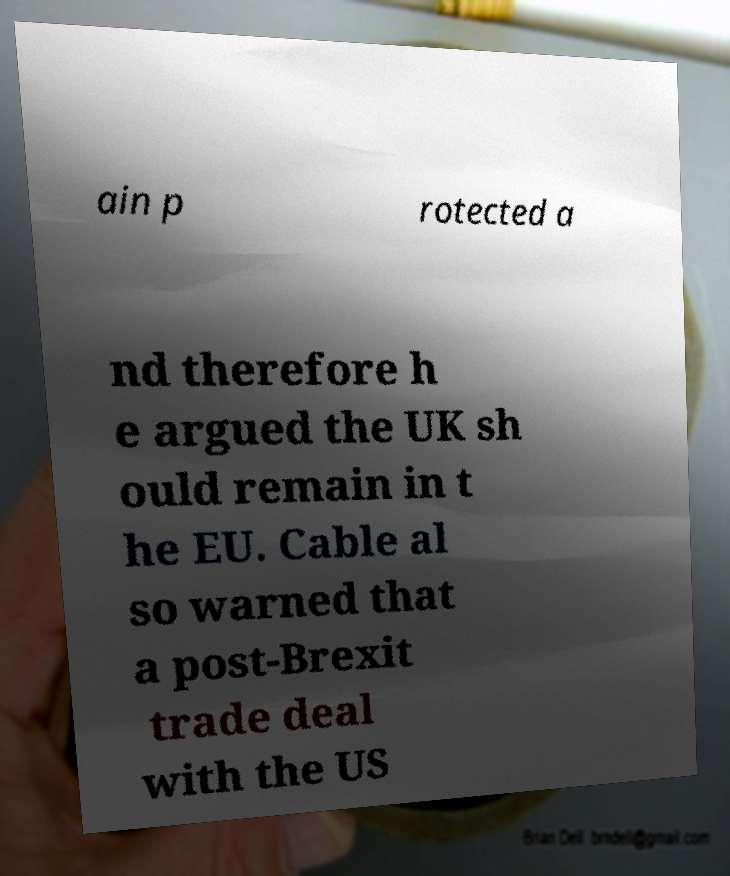For documentation purposes, I need the text within this image transcribed. Could you provide that? ain p rotected a nd therefore h e argued the UK sh ould remain in t he EU. Cable al so warned that a post-Brexit trade deal with the US 